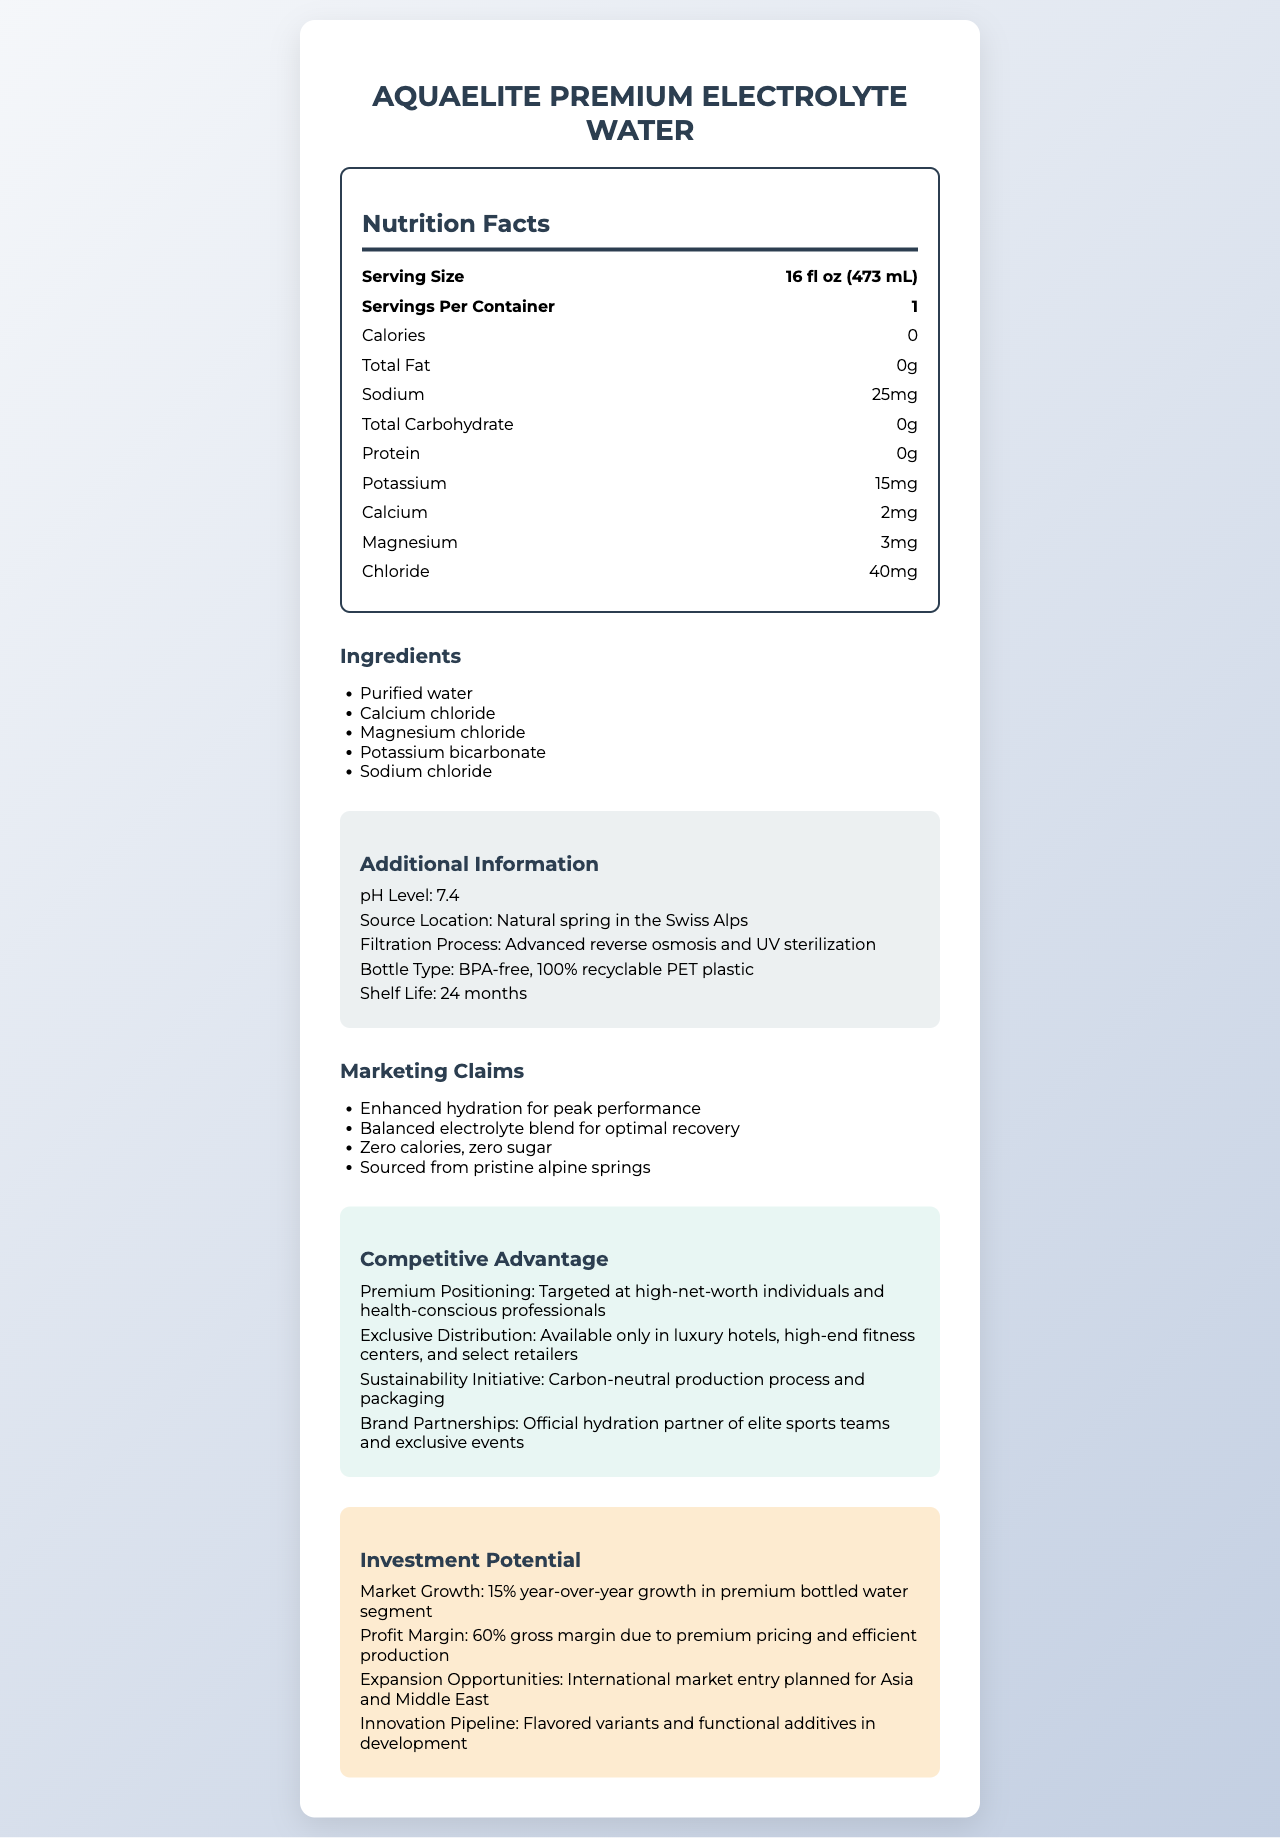what is the serving size for AquaElite Premium Electrolyte Water? The document lists the serving size as "16 fl oz (473 mL)" under the nutrition facts section.
Answer: 16 fl oz (473 mL) how much sodium is in one serving of this bottled water? The sodium content per serving is stated as "25mg" in the nutrition facts section.
Answer: 25mg which ingredient is listed first in the list of ingredients? The ingredient list shows "Purified water" as the first ingredient.
Answer: Purified water what is the shelf life of this product? The additional information section states the shelf life as "24 months".
Answer: 24 months what type of plastic is used in the bottle? The document mentions the bottle type as "BPA-free, 100% recyclable PET plastic" in the additional information section.
Answer: BPA-free, 100% recyclable PET plastic what is the pH level of AquaElite Premium Electrolyte Water? The pH level is listed as 7.4 in the additional information section.
Answer: 7.4 what unique selling point is targeted at high-net-worth individuals and health-conscious professionals? A. Zero calories B. Premium positioning C. Carbon-neutral production The document mentions "Premium Positioning: Targeted at high-net-worth individuals and health-conscious professionals" under the competitive advantage section.
Answer: B where is the source location of the water? A. American Rockies B. Swiss Alps C. Andes Mountains D. Himalayas The source location is listed as "Natural spring in the Swiss Alps" in the additional information section.
Answer: B is this product primarily marketed for enhanced hydration? (Yes/No) One of the marketing claims is "Enhanced hydration for peak performance".
Answer: Yes what kind of events and teams are partnered with this brand? The competitive advantage section states that the brand is the "Official hydration partner of elite sports teams and exclusive events".
Answer: Elite sports teams and exclusive events who could be the primary target customer for this product? The competitive advantage section highlights a premium positioning targeted at high-net-worth individuals and health-conscious professionals.
Answer: High-net-worth individuals and health-conscious professionals what is the gross margin of AquaElite Premium Electrolyte Water? The investment potential section states the profit margin as "60% gross margin".
Answer: 60% summarize the AquaElite Premium Electrolyte Water nutrition and marketing information The document details the product's nutrition facts, marketing claims, competitive advantages, and investment potential. Key aspects include its zero-calorie and electrolyte-rich composition, premium and environmentally friendly positioning, strong market performance, and aimed at elite distribution channels.
Answer: AquaElite Premium Electrolyte Water is a zero-calorie, electrolyte-enhanced premium bottled water sourced from the Swiss Alps. It features a balanced blend of calcium, magnesium, potassium, and sodium, using BPA-free, recyclable PET plastic bottles. The product targets high-net-worth individuals and health-conscious professionals, focusing on enhanced hydration and optimal recovery. The brand has a strong market growth rate and high profit margin, with plans for international expansion and new product variants. Competitive advantages include exclusive distribution, sustainability initiatives, and elite brand partnerships. what is the mineral content of the water? The document lists individual minerals like calcium, magnesium, potassium, and chloride, but it does not provide their total mineral content or sum.
Answer: Cannot be determined 